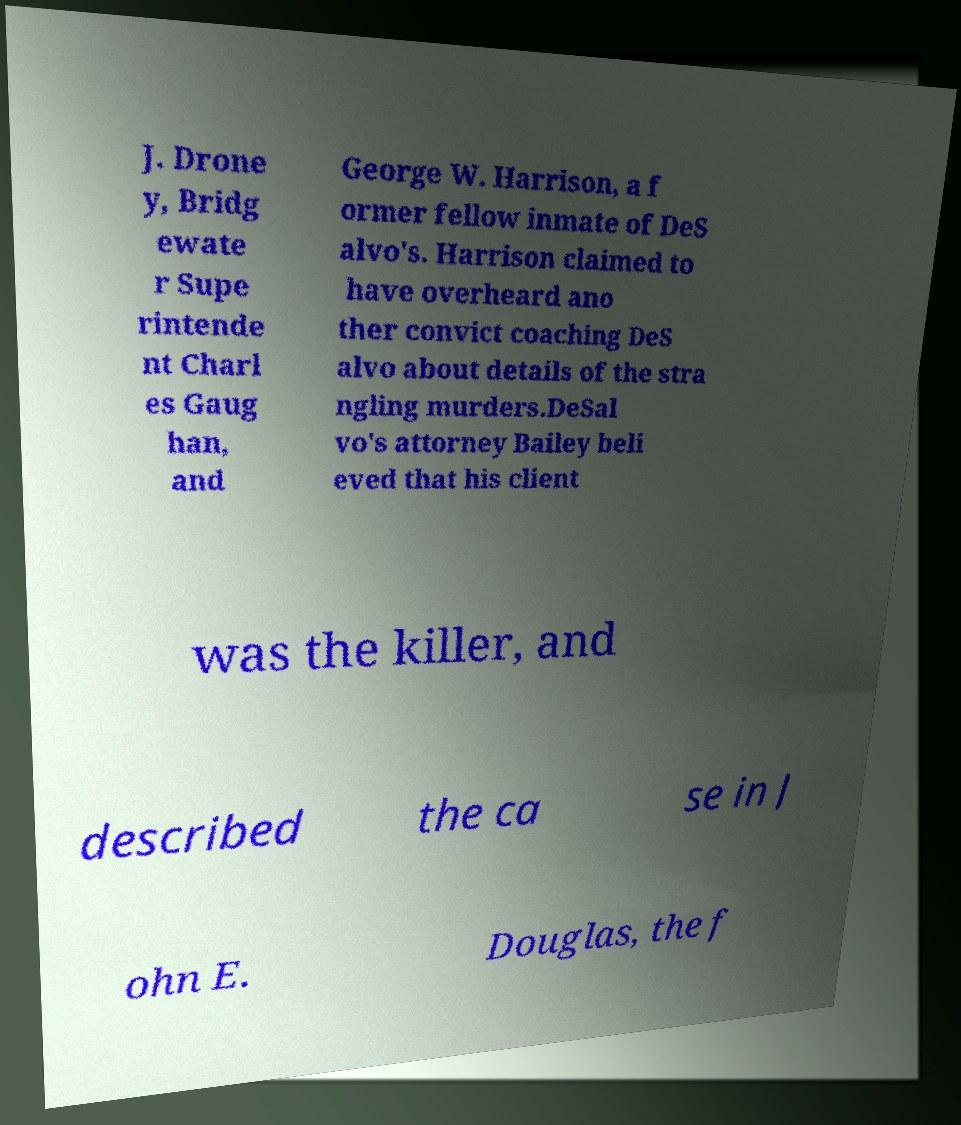Please identify and transcribe the text found in this image. J. Drone y, Bridg ewate r Supe rintende nt Charl es Gaug han, and George W. Harrison, a f ormer fellow inmate of DeS alvo's. Harrison claimed to have overheard ano ther convict coaching DeS alvo about details of the stra ngling murders.DeSal vo's attorney Bailey beli eved that his client was the killer, and described the ca se in J ohn E. Douglas, the f 